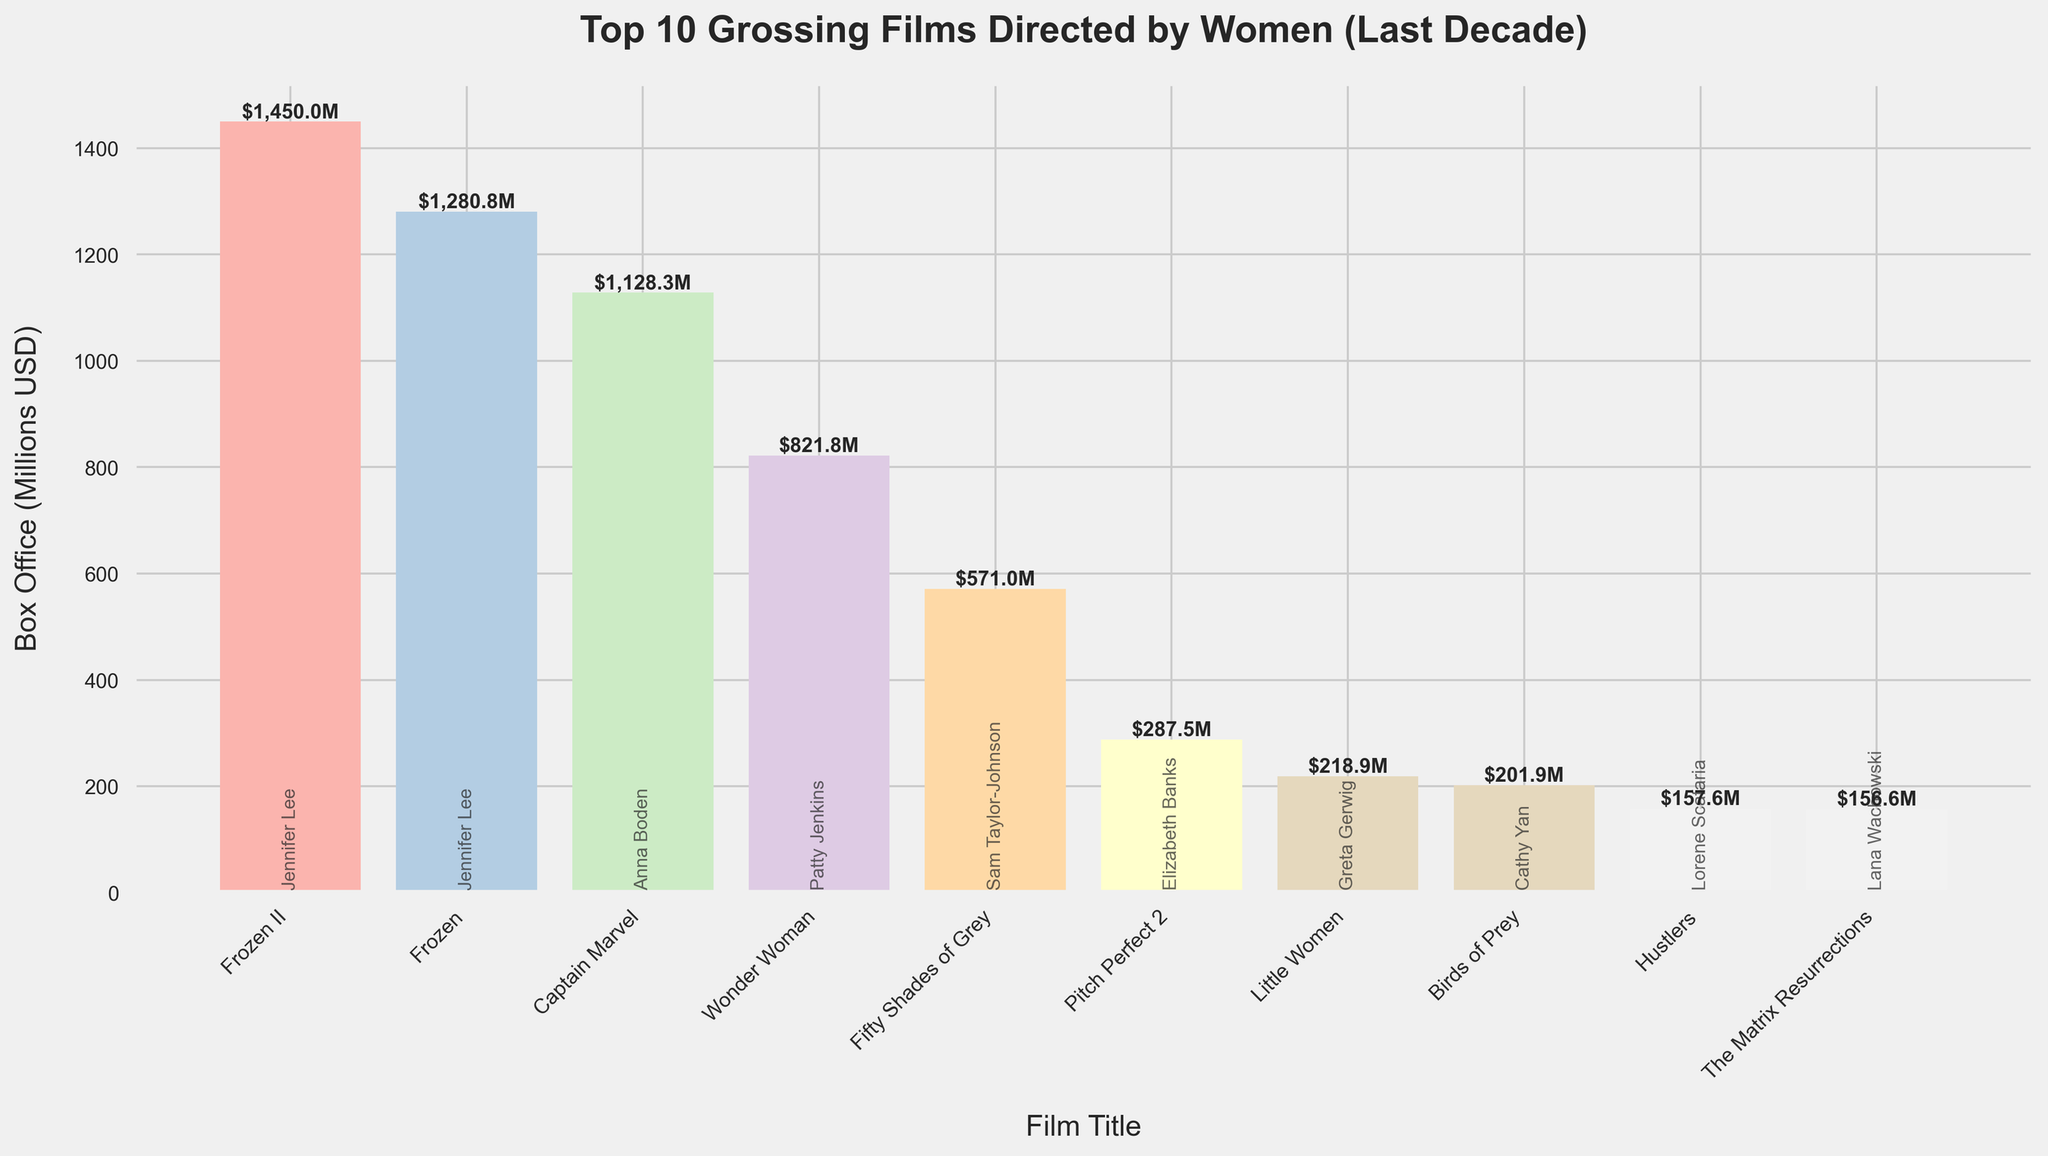Which film has the highest box office gross? Look for the tallest bar in the bar chart, which corresponds to "Frozen II" with a box office of $1,450.0 million.
Answer: Frozen II What’s the combined box office gross of the two films directed by Jennifer Lee? Identify the two bars for "Frozen" and "Frozen II." Their combined box office is 1,280.8 + 1,450.0 = 2,730.8 million USD.
Answer: 2,730.8 million USD Which film directed by a woman had the lowest box office gross among the top 10? Locate the shortest bar in the bar chart, which corresponds to "Lady Bird" with a box office of $78.9 million.
Answer: Lady Bird Compare the box office gross of "Captain Marvel" and "Wonder Woman"; which one is higher and by how much? Identify the bars for "Captain Marvel" ($1,128.3 million) and "Wonder Woman" ($821.8 million). The difference is 1,128.3 - 821.8 = 306.5 million USD.
Answer: Captain Marvel, 306.5 million USD How many films directed by women crossed the $1 billion mark in the last decade according to the chart? Count the bars with a box office gross above $1 billion: "Captain Marvel", "Frozen", and "Frozen II" are the films that fit this criterion.
Answer: 3 Which director has more films in the top 10 list: Greta Gerwig or Jennifer Lee? Find the occurrences of bars labeled with "Greta Gerwig" (2: "Lady Bird" and "Little Women") and "Jennifer Lee" (2: "Frozen" and "Frozen II").
Answer: Both directors have 2 films each What is the average box office gross of the top 10 films? Sum the box office gross of all top 10 films and divide by 10: (1,450.0 + 1,280.8 + 1,128.3 + 821.8 + 571.0 + 287.5 + 218.9 + 201.9 + 157.6 + 132.7)/10 = 6250.5/10 = 625.05 million USD.
Answer: 625.05 million USD Which film directed by Ava DuVernay made it to the top 10 list, and what is its box office gross? Locate the bar labeled with "Ava DuVernay," which corresponds to "A Wrinkle in Time" with a box office of $132.7 million.
Answer: A Wrinkle in Time, 132.7 million USD Among the top 10, how many films were released in 2019? Identify bars corresponding to films released in 2019: "Captain Marvel", "Frozen II", "Little Women."
Answer: 3 